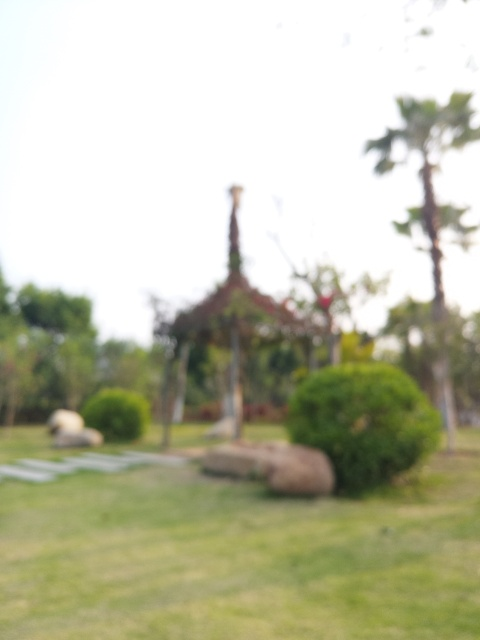What is the issue with the image quality?
A. The image has serious focus issues resulting in a blurry picture.
B. The image has perfect focus and is crystal clear.
C. The image has a slight focus issue, resulting in a slightly blurry picture.
Answer with the option's letter from the given choices directly.
 A. 